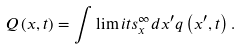<formula> <loc_0><loc_0><loc_500><loc_500>Q \left ( x , t \right ) = \int \lim i t s _ { x } ^ { \infty } d x ^ { \prime } q \left ( x ^ { \prime } , t \right ) .</formula> 